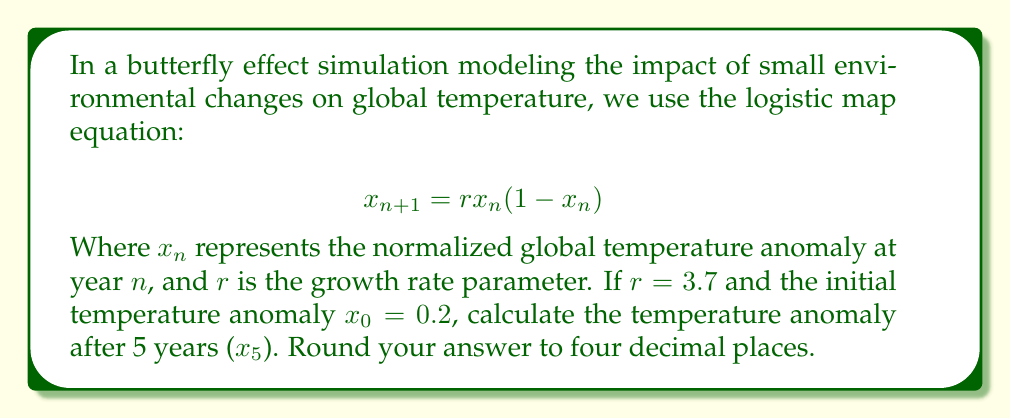Solve this math problem. To solve this problem, we need to iterate the logistic map equation for 5 years:

1) For $n = 0$:
   $x_1 = 3.7 \cdot 0.2 \cdot (1-0.2) = 3.7 \cdot 0.2 \cdot 0.8 = 0.592$

2) For $n = 1$:
   $x_2 = 3.7 \cdot 0.592 \cdot (1-0.592) = 3.7 \cdot 0.592 \cdot 0.408 = 0.8935744$

3) For $n = 2$:
   $x_3 = 3.7 \cdot 0.8935744 \cdot (1-0.8935744) = 3.7 \cdot 0.8935744 \cdot 0.1064256 = 0.3516592$

4) For $n = 3$:
   $x_4 = 3.7 \cdot 0.3516592 \cdot (1-0.3516592) = 3.7 \cdot 0.3516592 \cdot 0.6483408 = 0.8425234$

5) For $n = 4$:
   $x_5 = 3.7 \cdot 0.8425234 \cdot (1-0.8425234) = 3.7 \cdot 0.8425234 \cdot 0.1574766 = 0.4911256$

Rounding to four decimal places: $x_5 \approx 0.4911$
Answer: 0.4911 